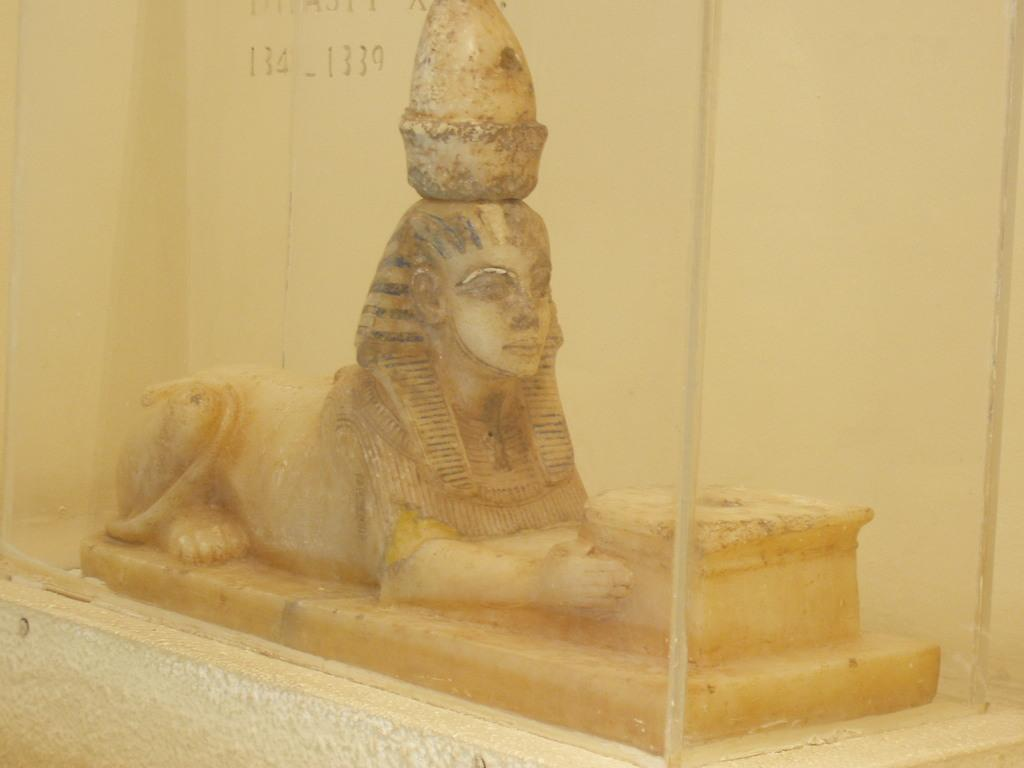What is the main subject of the image? There is a sculpture in the image. Can you tell me how many clovers are growing around the sculpture in the image? There is no information about clovers or any vegetation in the image; it only features a sculpture. 